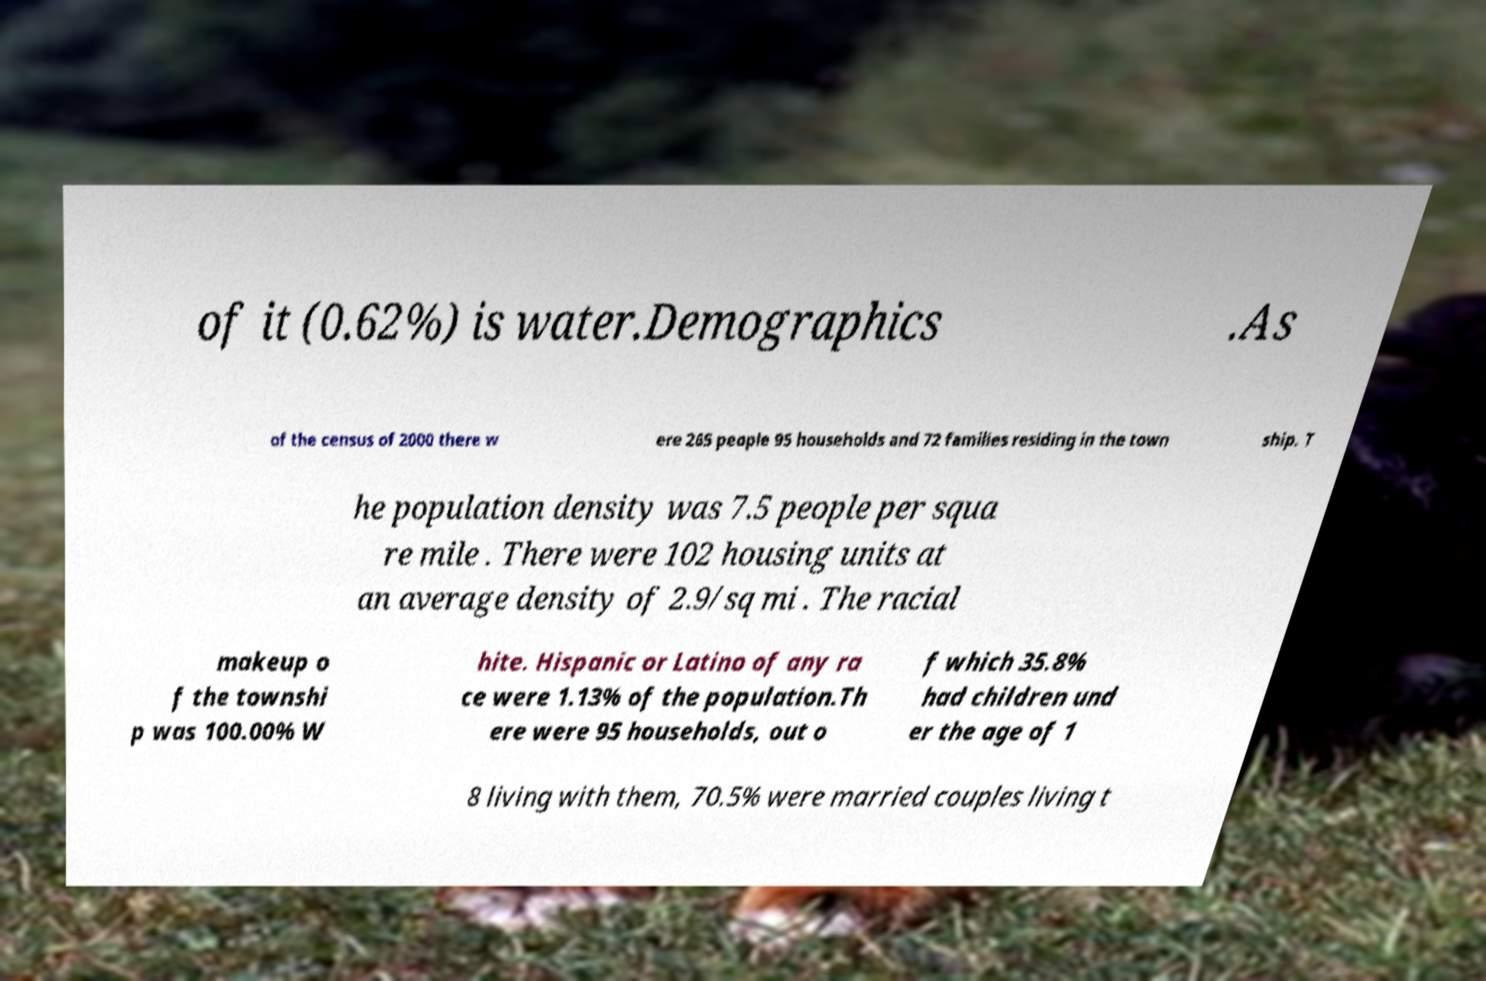I need the written content from this picture converted into text. Can you do that? of it (0.62%) is water.Demographics .As of the census of 2000 there w ere 265 people 95 households and 72 families residing in the town ship. T he population density was 7.5 people per squa re mile . There were 102 housing units at an average density of 2.9/sq mi . The racial makeup o f the townshi p was 100.00% W hite. Hispanic or Latino of any ra ce were 1.13% of the population.Th ere were 95 households, out o f which 35.8% had children und er the age of 1 8 living with them, 70.5% were married couples living t 